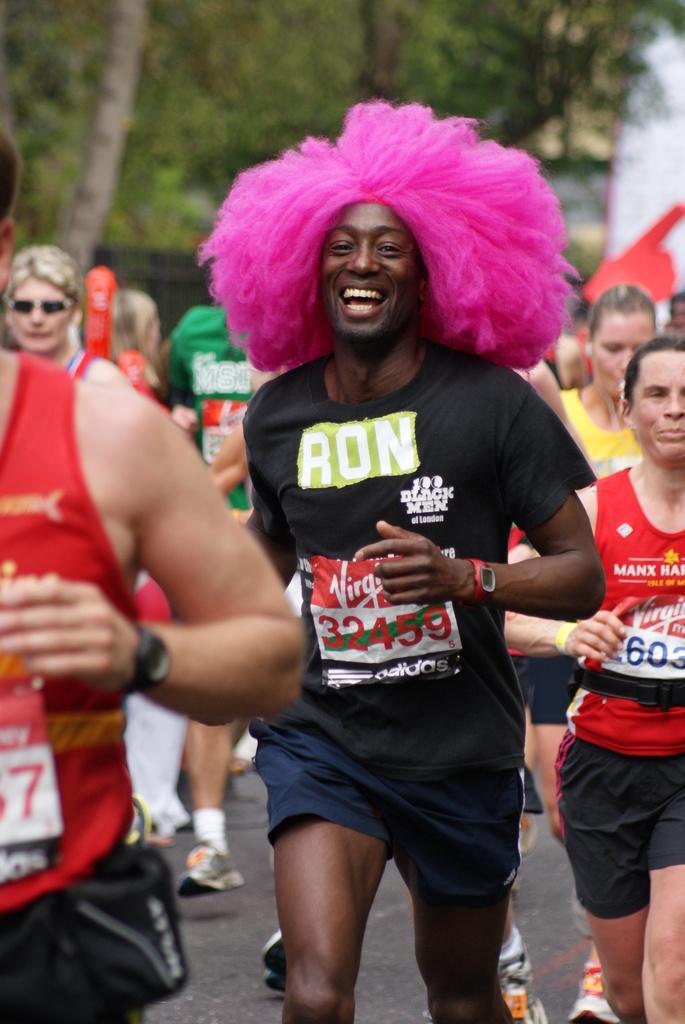In one or two sentences, can you explain what this image depicts? In this picture there is a person with black t-shirt is running and smiling and there are group of people running. At the back there is a board and there are trees. At the bottom there is a road. 